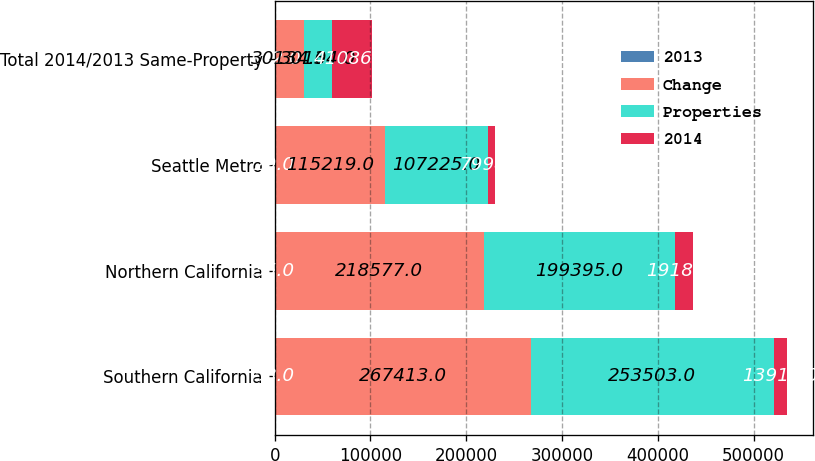Convert chart to OTSL. <chart><loc_0><loc_0><loc_500><loc_500><stacked_bar_chart><ecel><fcel>Southern California<fcel>Northern California<fcel>Seattle Metro<fcel>Total 2014/2013 Same-Property<nl><fcel>2013<fcel>58<fcel>35<fcel>29<fcel>122<nl><fcel>Change<fcel>267413<fcel>218577<fcel>115219<fcel>30134<nl><fcel>Properties<fcel>253503<fcel>199395<fcel>107225<fcel>30134<nl><fcel>2014<fcel>13910<fcel>19182<fcel>7994<fcel>41086<nl></chart> 